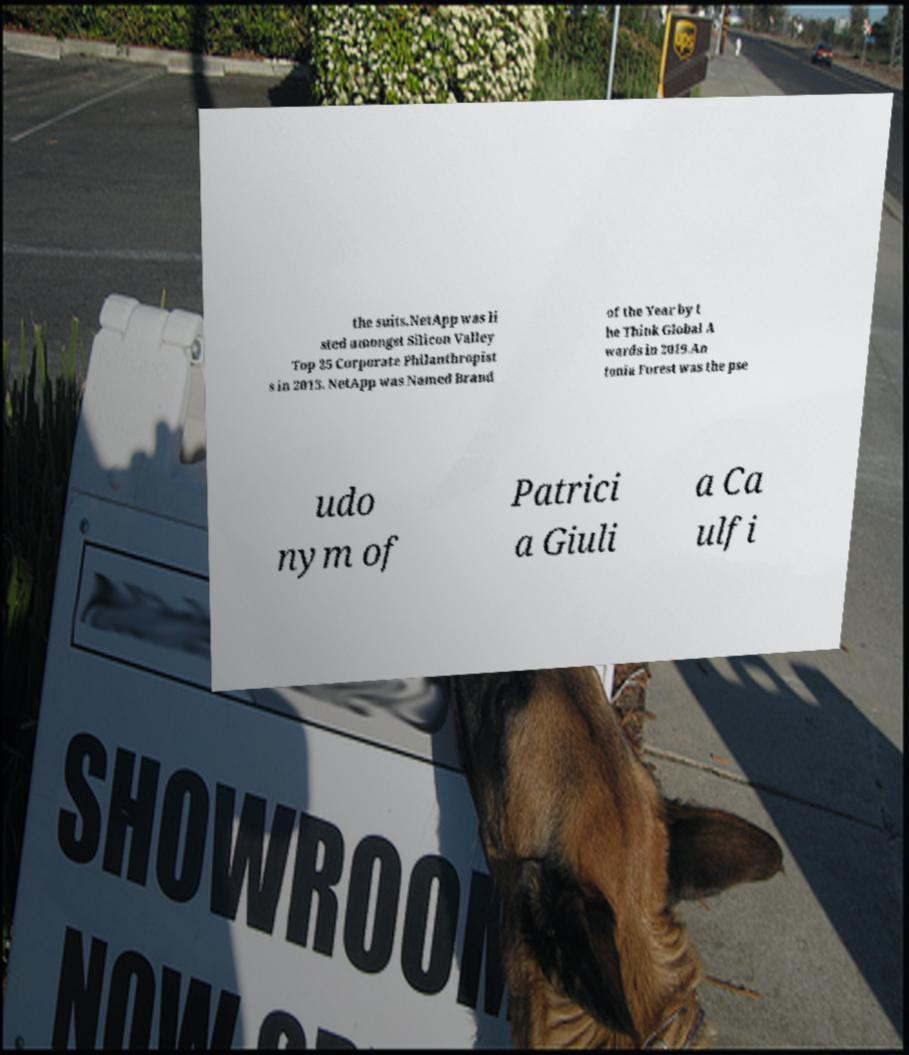Could you assist in decoding the text presented in this image and type it out clearly? the suits.NetApp was li sted amongst Silicon Valley Top 25 Corporate Philanthropist s in 2013. NetApp was Named Brand of the Year by t he Think Global A wards in 2019.An tonia Forest was the pse udo nym of Patrici a Giuli a Ca ulfi 